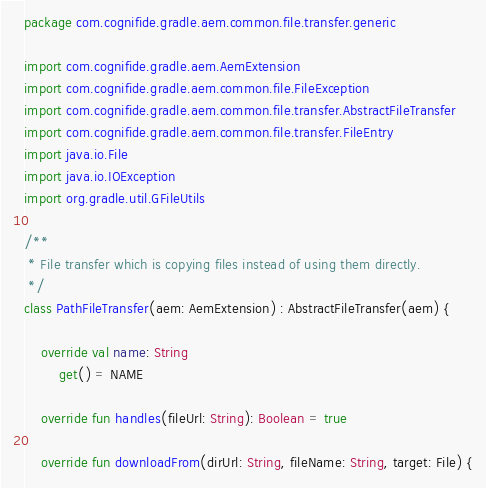<code> <loc_0><loc_0><loc_500><loc_500><_Kotlin_>package com.cognifide.gradle.aem.common.file.transfer.generic

import com.cognifide.gradle.aem.AemExtension
import com.cognifide.gradle.aem.common.file.FileException
import com.cognifide.gradle.aem.common.file.transfer.AbstractFileTransfer
import com.cognifide.gradle.aem.common.file.transfer.FileEntry
import java.io.File
import java.io.IOException
import org.gradle.util.GFileUtils

/**
 * File transfer which is copying files instead of using them directly.
 */
class PathFileTransfer(aem: AemExtension) : AbstractFileTransfer(aem) {

    override val name: String
        get() = NAME

    override fun handles(fileUrl: String): Boolean = true

    override fun downloadFrom(dirUrl: String, fileName: String, target: File) {</code> 